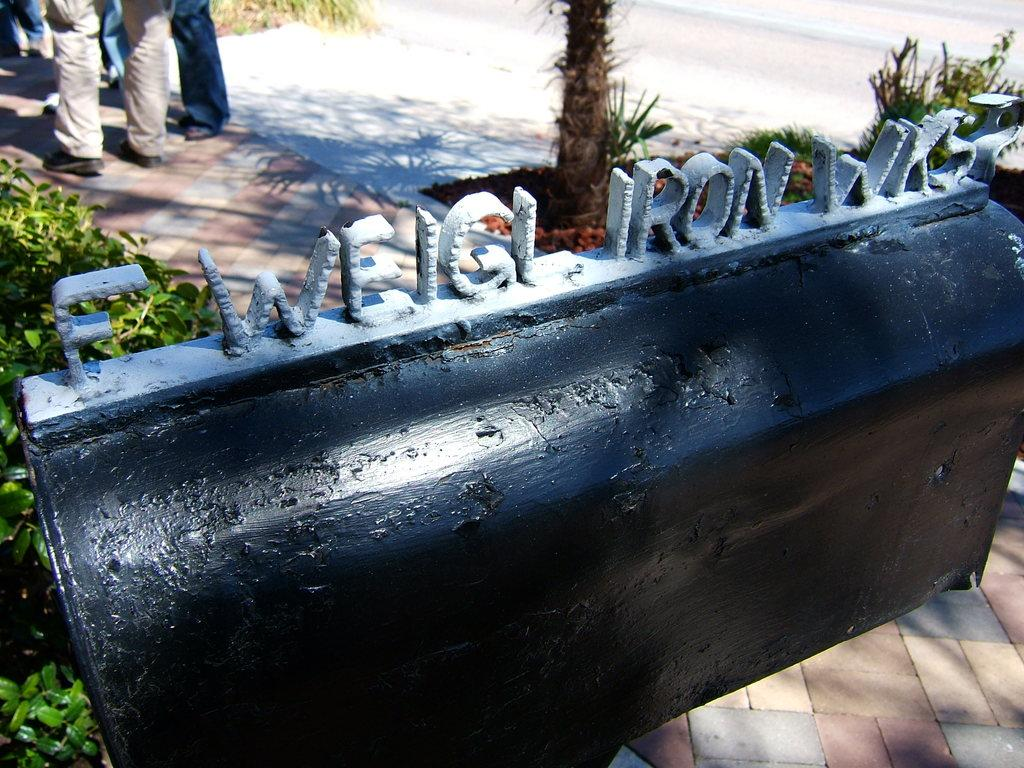What type of structure is present in the image? There is an iron gate with text in the image. What type of vegetation can be seen in the image? There are bushes and trees in the image. Are there any people visible in the image? Yes, there are persons standing on the floor in the image. What month is it in the image? The month cannot be determined from the image, as there is no information about the time of year or any calendar references. 